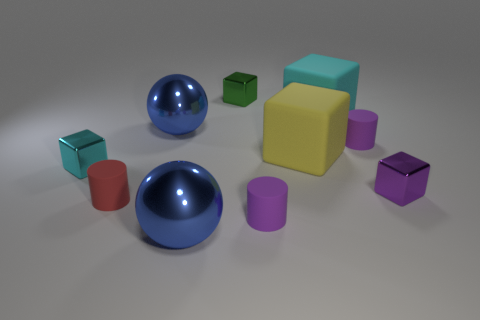Subtract all cyan matte blocks. How many blocks are left? 4 Subtract all purple cylinders. How many cylinders are left? 1 Subtract all cylinders. How many objects are left? 7 Subtract all green cylinders. How many cyan cubes are left? 2 Subtract 1 cyan blocks. How many objects are left? 9 Subtract 2 spheres. How many spheres are left? 0 Subtract all red spheres. Subtract all blue cylinders. How many spheres are left? 2 Subtract all cyan rubber objects. Subtract all purple metallic cubes. How many objects are left? 8 Add 8 large blue metallic balls. How many large blue metallic balls are left? 10 Add 4 tiny metal blocks. How many tiny metal blocks exist? 7 